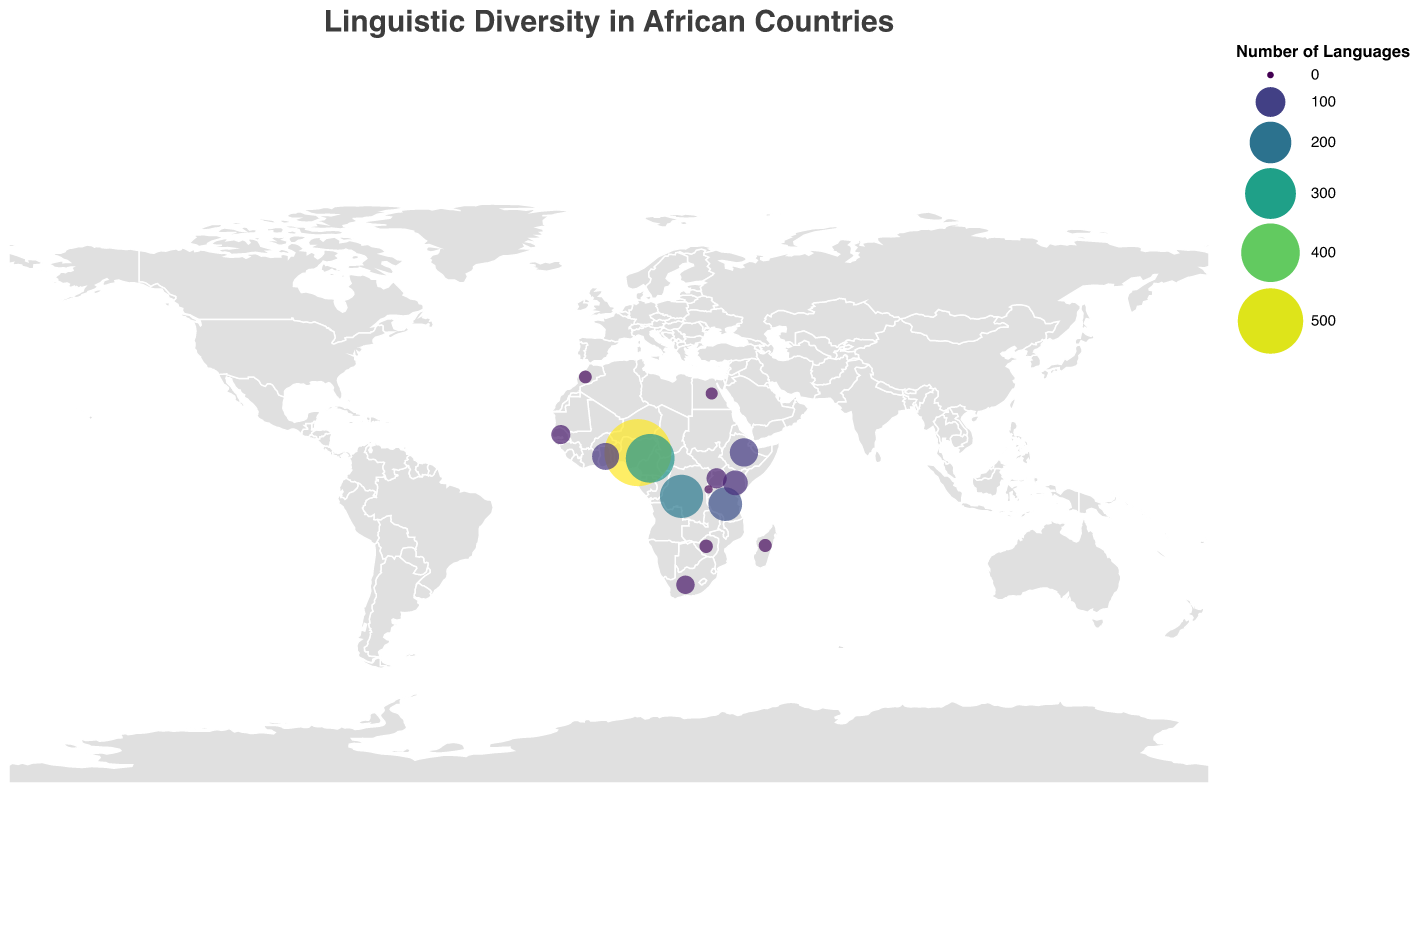How many languages are spoken in Nigeria? Look for Nigeria on the map and check the size/color of the circle representing it. The tooltip should show that 526 languages are spoken.
Answer: 526 Which two countries have the highest linguistic diversity, and how many languages do they have? Identify the countries with the largest circles and brightest colors. Nigeria has 526 languages and Cameroon has 275 languages.
Answer: Nigeria (526), Cameroon (275) Compare the number of languages spoken in Kenya and Uganda. Which country has more linguistic diversity and by how much? Locate both Kenya and Uganda on the map and check the numbers indicated by the size/color of their circles. Kenya has 68 languages and Uganda has 43 languages. The difference is 68 - 43 = 25.
Answer: Kenya has 25 more languages Which country has the least linguistic diversity, and how many languages are spoken there? Look for the smallest and least bright circle on the map. Rwanda has the least diversity with 3 languages.
Answer: Rwanda (3) What is the sum of the languages spoken in Egypt, Morocco, and Madagascar? Locate these countries on the map and sum the number of languages shown in their tooltips. Egypt has 12, Morocco has 14, and Madagascar has 15. Sum: 12 + 14 + 15 = 41.
Answer: 41 How does the linguistic diversity in Democratic Republic of the Congo compare to Tanzania? Find the circles for the Democratic Republic of the Congo and Tanzania and note the number of languages. Democratic Republic of the Congo has 215 languages, and Tanzania has 129. Democratic Republic of the Congo has more.
Answer: Democratic Republic of the Congo has more What is the average number of languages spoken in Ghana, Uganda, and South Africa? Locate these countries on the map and get the numbers from the tooltips: Ghana (81), Uganda (43), South Africa (35). Average: (81 + 43 + 35) / 3 = 159 / 3 = 53.
Answer: 53 Which country located in southern Africa has fewer than 20 languages spoken? Identify countries located in southern Africa and look for one with a small circle indicating fewer than 20. Zimbabwe is the country with 16 languages.
Answer: Zimbabwe 